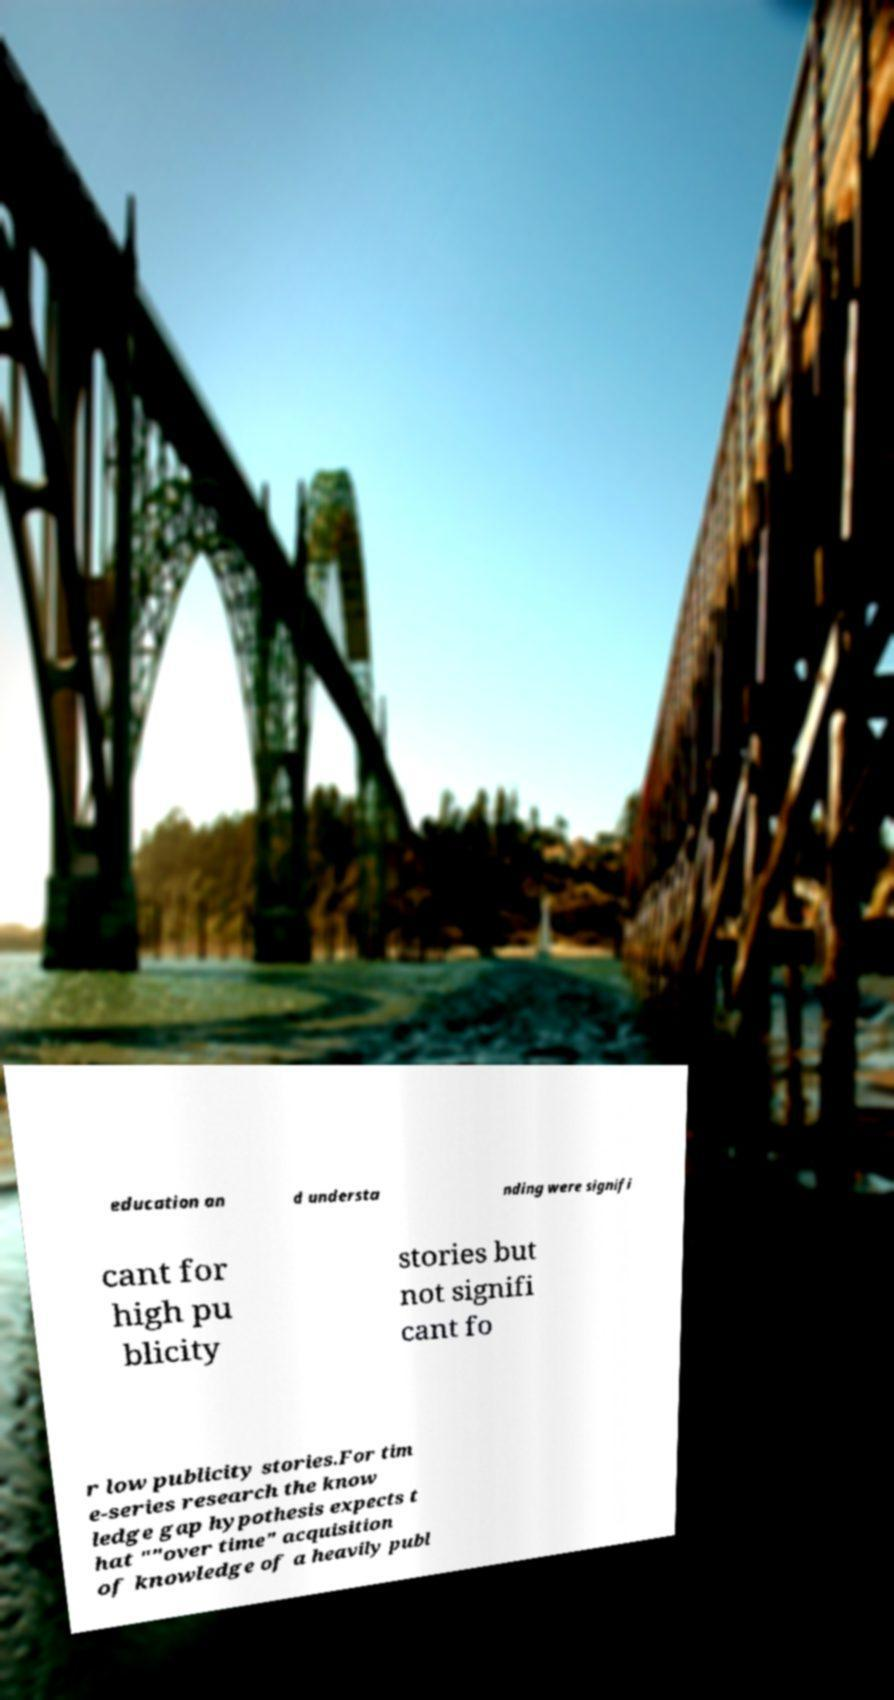Can you accurately transcribe the text from the provided image for me? education an d understa nding were signifi cant for high pu blicity stories but not signifi cant fo r low publicity stories.For tim e-series research the know ledge gap hypothesis expects t hat ""over time" acquisition of knowledge of a heavily publ 